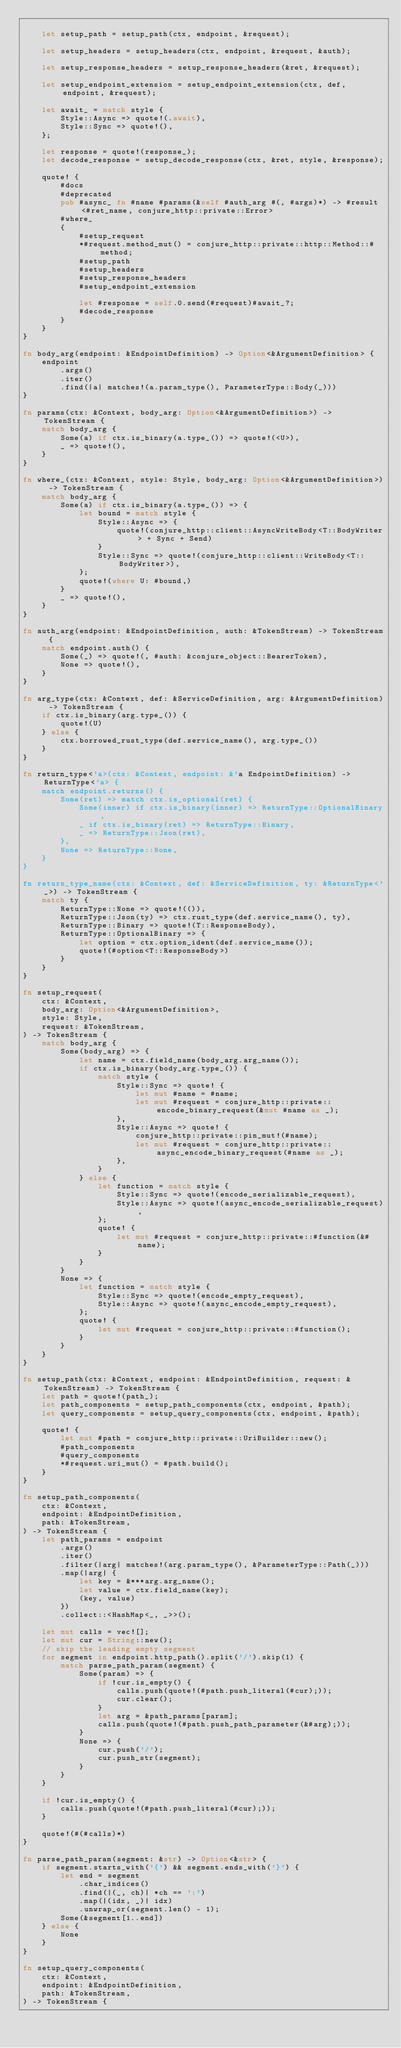Convert code to text. <code><loc_0><loc_0><loc_500><loc_500><_Rust_>
    let setup_path = setup_path(ctx, endpoint, &request);

    let setup_headers = setup_headers(ctx, endpoint, &request, &auth);

    let setup_response_headers = setup_response_headers(&ret, &request);

    let setup_endpoint_extension = setup_endpoint_extension(ctx, def, endpoint, &request);

    let await_ = match style {
        Style::Async => quote!(.await),
        Style::Sync => quote!(),
    };

    let response = quote!(response_);
    let decode_response = setup_decode_response(ctx, &ret, style, &response);

    quote! {
        #docs
        #deprecated
        pub #async_ fn #name #params(&self #auth_arg #(, #args)*) -> #result<#ret_name, conjure_http::private::Error>
        #where_
        {
            #setup_request
            *#request.method_mut() = conjure_http::private::http::Method::#method;
            #setup_path
            #setup_headers
            #setup_response_headers
            #setup_endpoint_extension

            let #response = self.0.send(#request)#await_?;
            #decode_response
        }
    }
}

fn body_arg(endpoint: &EndpointDefinition) -> Option<&ArgumentDefinition> {
    endpoint
        .args()
        .iter()
        .find(|a| matches!(a.param_type(), ParameterType::Body(_)))
}

fn params(ctx: &Context, body_arg: Option<&ArgumentDefinition>) -> TokenStream {
    match body_arg {
        Some(a) if ctx.is_binary(a.type_()) => quote!(<U>),
        _ => quote!(),
    }
}

fn where_(ctx: &Context, style: Style, body_arg: Option<&ArgumentDefinition>) -> TokenStream {
    match body_arg {
        Some(a) if ctx.is_binary(a.type_()) => {
            let bound = match style {
                Style::Async => {
                    quote!(conjure_http::client::AsyncWriteBody<T::BodyWriter> + Sync + Send)
                }
                Style::Sync => quote!(conjure_http::client::WriteBody<T::BodyWriter>),
            };
            quote!(where U: #bound,)
        }
        _ => quote!(),
    }
}

fn auth_arg(endpoint: &EndpointDefinition, auth: &TokenStream) -> TokenStream {
    match endpoint.auth() {
        Some(_) => quote!(, #auth: &conjure_object::BearerToken),
        None => quote!(),
    }
}

fn arg_type(ctx: &Context, def: &ServiceDefinition, arg: &ArgumentDefinition) -> TokenStream {
    if ctx.is_binary(arg.type_()) {
        quote!(U)
    } else {
        ctx.borrowed_rust_type(def.service_name(), arg.type_())
    }
}

fn return_type<'a>(ctx: &Context, endpoint: &'a EndpointDefinition) -> ReturnType<'a> {
    match endpoint.returns() {
        Some(ret) => match ctx.is_optional(ret) {
            Some(inner) if ctx.is_binary(inner) => ReturnType::OptionalBinary,
            _ if ctx.is_binary(ret) => ReturnType::Binary,
            _ => ReturnType::Json(ret),
        },
        None => ReturnType::None,
    }
}

fn return_type_name(ctx: &Context, def: &ServiceDefinition, ty: &ReturnType<'_>) -> TokenStream {
    match ty {
        ReturnType::None => quote!(()),
        ReturnType::Json(ty) => ctx.rust_type(def.service_name(), ty),
        ReturnType::Binary => quote!(T::ResponseBody),
        ReturnType::OptionalBinary => {
            let option = ctx.option_ident(def.service_name());
            quote!(#option<T::ResponseBody>)
        }
    }
}

fn setup_request(
    ctx: &Context,
    body_arg: Option<&ArgumentDefinition>,
    style: Style,
    request: &TokenStream,
) -> TokenStream {
    match body_arg {
        Some(body_arg) => {
            let name = ctx.field_name(body_arg.arg_name());
            if ctx.is_binary(body_arg.type_()) {
                match style {
                    Style::Sync => quote! {
                        let mut #name = #name;
                        let mut #request = conjure_http::private::encode_binary_request(&mut #name as _);
                    },
                    Style::Async => quote! {
                        conjure_http::private::pin_mut!(#name);
                        let mut #request = conjure_http::private::async_encode_binary_request(#name as _);
                    },
                }
            } else {
                let function = match style {
                    Style::Sync => quote!(encode_serializable_request),
                    Style::Async => quote!(async_encode_serializable_request),
                };
                quote! {
                    let mut #request = conjure_http::private::#function(&#name);
                }
            }
        }
        None => {
            let function = match style {
                Style::Sync => quote!(encode_empty_request),
                Style::Async => quote!(async_encode_empty_request),
            };
            quote! {
                let mut #request = conjure_http::private::#function();
            }
        }
    }
}

fn setup_path(ctx: &Context, endpoint: &EndpointDefinition, request: &TokenStream) -> TokenStream {
    let path = quote!(path_);
    let path_components = setup_path_components(ctx, endpoint, &path);
    let query_components = setup_query_components(ctx, endpoint, &path);

    quote! {
        let mut #path = conjure_http::private::UriBuilder::new();
        #path_components
        #query_components
        *#request.uri_mut() = #path.build();
    }
}

fn setup_path_components(
    ctx: &Context,
    endpoint: &EndpointDefinition,
    path: &TokenStream,
) -> TokenStream {
    let path_params = endpoint
        .args()
        .iter()
        .filter(|arg| matches!(arg.param_type(), &ParameterType::Path(_)))
        .map(|arg| {
            let key = &***arg.arg_name();
            let value = ctx.field_name(key);
            (key, value)
        })
        .collect::<HashMap<_, _>>();

    let mut calls = vec![];
    let mut cur = String::new();
    // skip the leading empty segment
    for segment in endpoint.http_path().split('/').skip(1) {
        match parse_path_param(segment) {
            Some(param) => {
                if !cur.is_empty() {
                    calls.push(quote!(#path.push_literal(#cur);));
                    cur.clear();
                }
                let arg = &path_params[param];
                calls.push(quote!(#path.push_path_parameter(&#arg);));
            }
            None => {
                cur.push('/');
                cur.push_str(segment);
            }
        }
    }

    if !cur.is_empty() {
        calls.push(quote!(#path.push_literal(#cur);));
    }

    quote!(#(#calls)*)
}

fn parse_path_param(segment: &str) -> Option<&str> {
    if segment.starts_with('{') && segment.ends_with('}') {
        let end = segment
            .char_indices()
            .find(|(_, ch)| *ch == ':')
            .map(|(idx, _)| idx)
            .unwrap_or(segment.len() - 1);
        Some(&segment[1..end])
    } else {
        None
    }
}

fn setup_query_components(
    ctx: &Context,
    endpoint: &EndpointDefinition,
    path: &TokenStream,
) -> TokenStream {</code> 